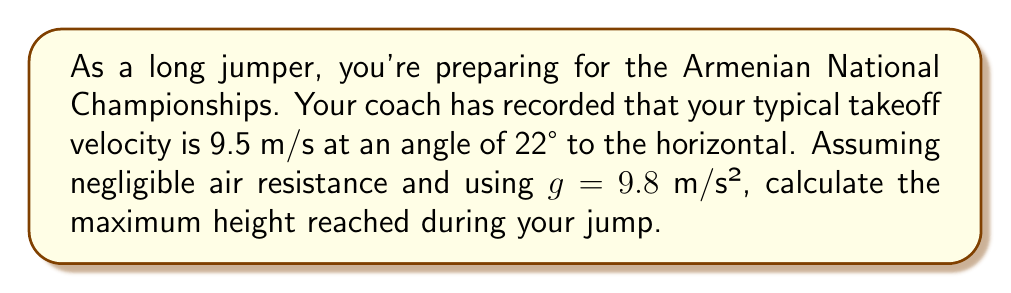Provide a solution to this math problem. To solve this problem, we'll use the equations of projectile motion. Let's break it down step-by-step:

1) First, we need to decompose the initial velocity into its horizontal and vertical components:

   $v_{0x} = v_0 \cos \theta = 9.5 \cos 22° = 8.81$ m/s
   $v_{0y} = v_0 \sin \theta = 9.5 \sin 22° = 3.56$ m/s

2) The maximum height is reached when the vertical velocity becomes zero. We can use the equation:

   $v_y = v_{0y} - gt$

3) At the highest point, $v_y = 0$, so:

   $0 = 3.56 - 9.8t$
   $t = \frac{3.56}{9.8} = 0.363$ s

4) Now that we know the time to reach the maximum height, we can use the equation:

   $y = v_{0y}t - \frac{1}{2}gt^2$

5) Substituting our values:

   $y = (3.56)(0.363) - \frac{1}{2}(9.8)(0.363)^2$
   $y = 1.29 - 0.65 = 0.64$ m

Therefore, the maximum height reached during the jump is 0.64 meters.
Answer: 0.64 m 